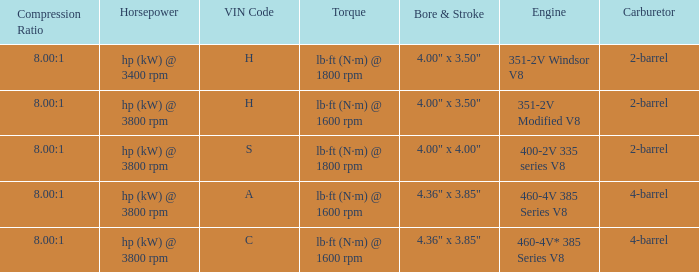What are the bore & stroke specifications for an engine with 4-barrel carburetor and VIN code of A? 4.36" x 3.85". 